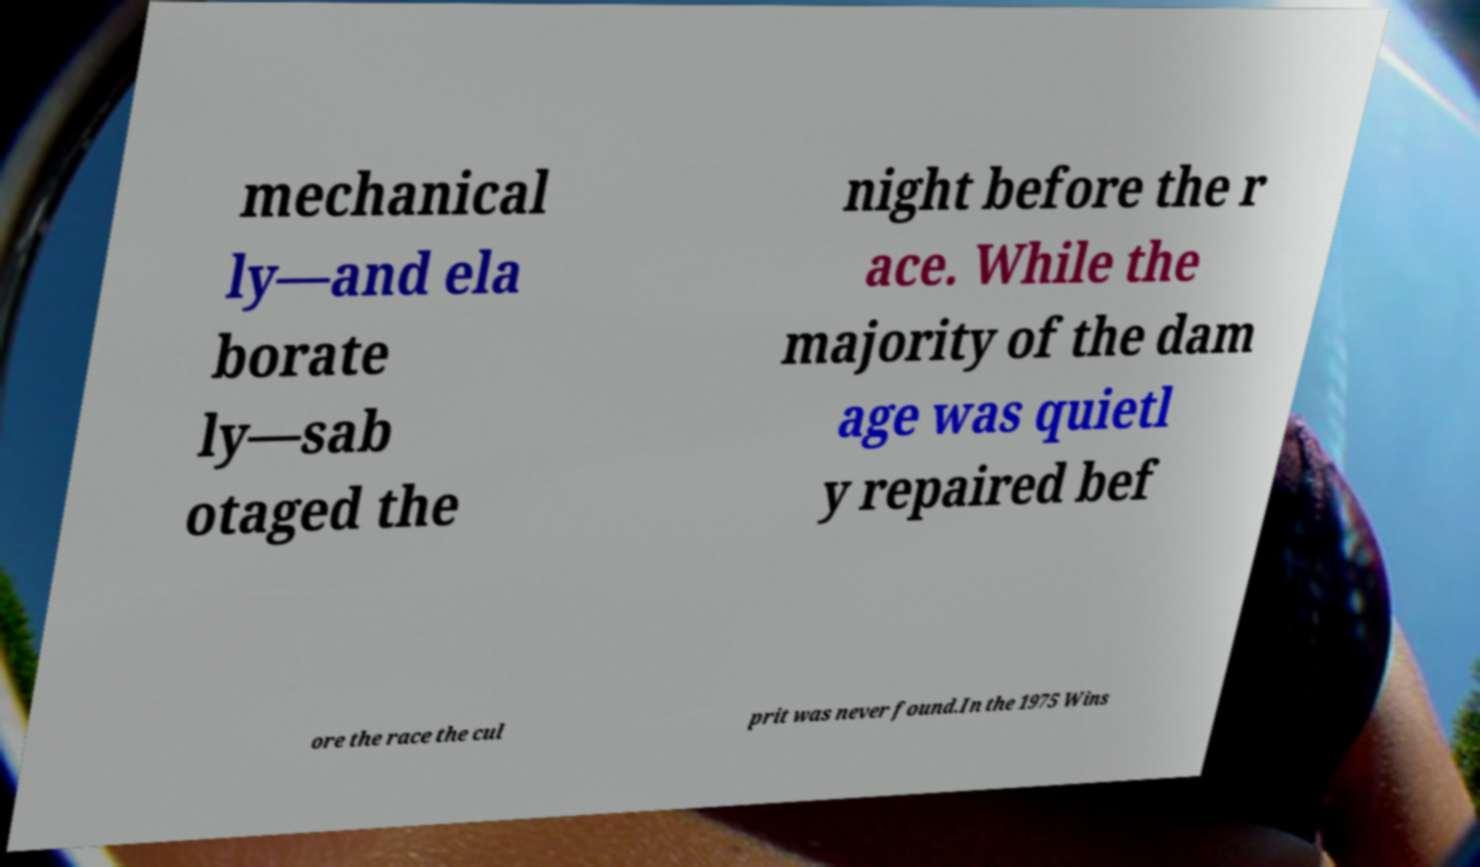What messages or text are displayed in this image? I need them in a readable, typed format. mechanical ly—and ela borate ly—sab otaged the night before the r ace. While the majority of the dam age was quietl y repaired bef ore the race the cul prit was never found.In the 1975 Wins 